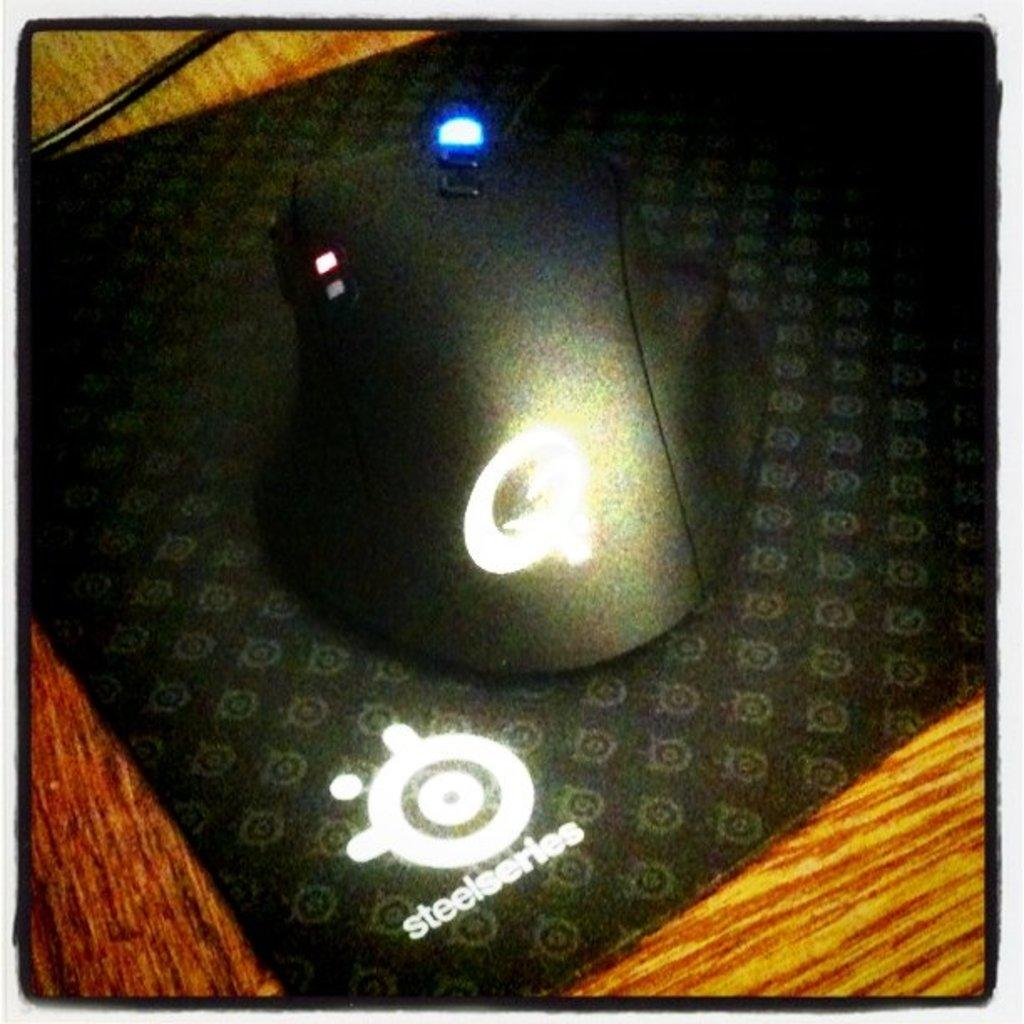<image>
Provide a brief description of the given image. A mouse and mouse pad that reads Steelseries. 